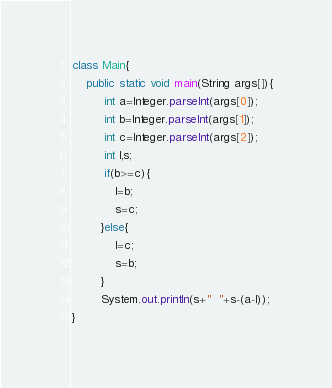Convert code to text. <code><loc_0><loc_0><loc_500><loc_500><_Java_>class Main{
    public static void main(String args[]){
         int a=Integer.parseInt(args[0]);
         int b=Integer.parseInt(args[1]);
         int c=Integer.parseInt(args[2]);
         int l,s;
         if(b>=c){
            l=b;
            s=c;
        }else{
            l=c;
            s=b;
        }
        System.out.println(s+"  "+s-(a-l));
}</code> 